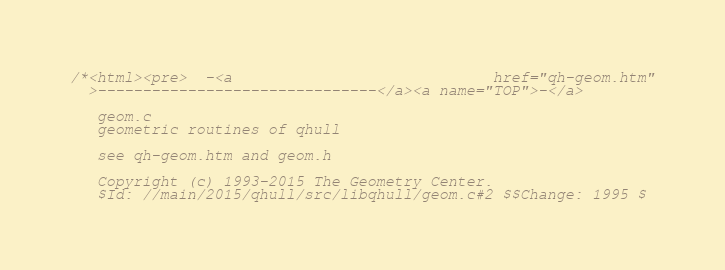Convert code to text. <code><loc_0><loc_0><loc_500><loc_500><_C_>/*<html><pre>  -<a                             href="qh-geom.htm"
  >-------------------------------</a><a name="TOP">-</a>

   geom.c
   geometric routines of qhull

   see qh-geom.htm and geom.h

   Copyright (c) 1993-2015 The Geometry Center.
   $Id: //main/2015/qhull/src/libqhull/geom.c#2 $$Change: 1995 $</code> 